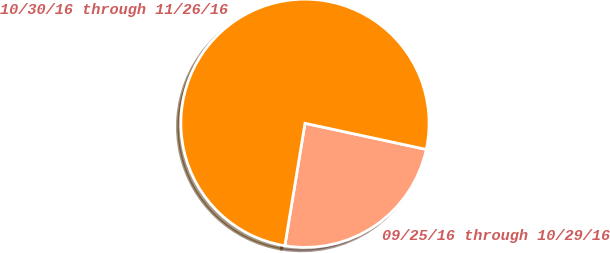Convert chart to OTSL. <chart><loc_0><loc_0><loc_500><loc_500><pie_chart><fcel>09/25/16 through 10/29/16<fcel>10/30/16 through 11/26/16<nl><fcel>24.22%<fcel>75.78%<nl></chart> 